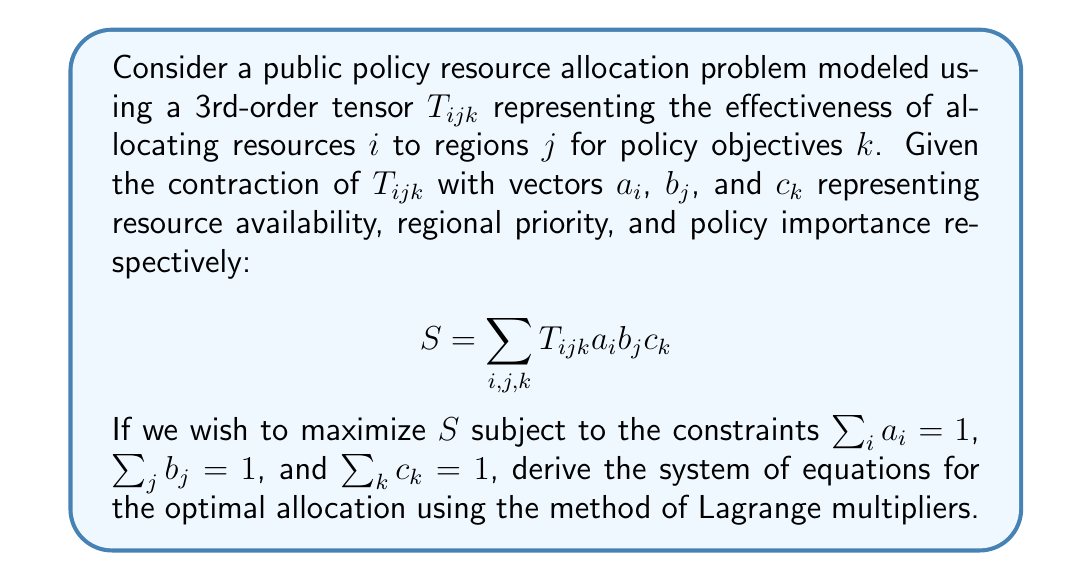Teach me how to tackle this problem. To solve this optimization problem using Lagrange multipliers, we follow these steps:

1) Form the Lagrangian function:
   $$L = \sum_{i,j,k} T_{ijk} a_i b_j c_k - \lambda(\sum_i a_i - 1) - \mu(\sum_j b_j - 1) - \nu(\sum_k c_k - 1)$$

2) Take partial derivatives with respect to $a_i$, $b_j$, $c_k$, $\lambda$, $\mu$, and $\nu$:

   $$\frac{\partial L}{\partial a_i} = \sum_{j,k} T_{ijk} b_j c_k - \lambda = 0$$
   $$\frac{\partial L}{\partial b_j} = \sum_{i,k} T_{ijk} a_i c_k - \mu = 0$$
   $$\frac{\partial L}{\partial c_k} = \sum_{i,j} T_{ijk} a_i b_j - \nu = 0$$
   $$\frac{\partial L}{\partial \lambda} = \sum_i a_i - 1 = 0$$
   $$\frac{\partial L}{\partial \mu} = \sum_j b_j - 1 = 0$$
   $$\frac{\partial L}{\partial \nu} = \sum_k c_k - 1 = 0$$

3) The system of equations for optimal allocation is thus:

   $$\sum_{j,k} T_{ijk} b_j c_k = \lambda, \quad \forall i$$
   $$\sum_{i,k} T_{ijk} a_i c_k = \mu, \quad \forall j$$
   $$\sum_{i,j} T_{ijk} a_i b_j = \nu, \quad \forall k$$
   $$\sum_i a_i = 1$$
   $$\sum_j b_j = 1$$
   $$\sum_k c_k = 1$$

This system of equations, along with the non-negativity constraints for $a_i$, $b_j$, and $c_k$, defines the optimal resource allocation.
Answer: $$\begin{cases}
\sum_{j,k} T_{ijk} b_j c_k = \lambda, \forall i \\
\sum_{i,k} T_{ijk} a_i c_k = \mu, \forall j \\
\sum_{i,j} T_{ijk} a_i b_j = \nu, \forall k \\
\sum_i a_i = \sum_j b_j = \sum_k c_k = 1
\end{cases}$$ 